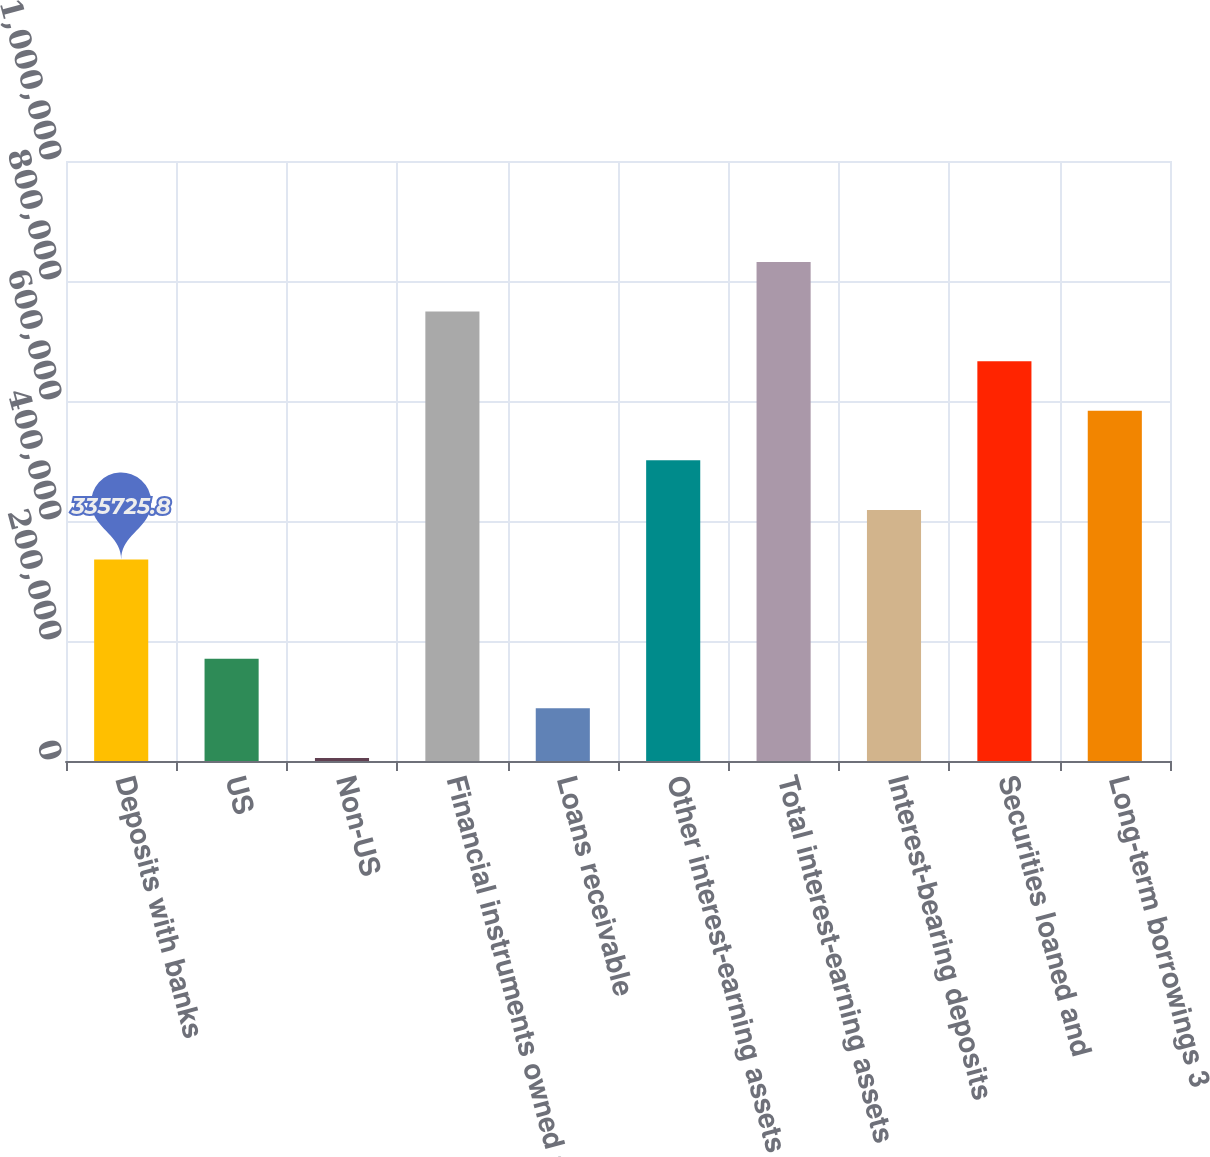<chart> <loc_0><loc_0><loc_500><loc_500><bar_chart><fcel>Deposits with banks<fcel>US<fcel>Non-US<fcel>Financial instruments owned at<fcel>Loans receivable<fcel>Other interest-earning assets<fcel>Total interest-earning assets<fcel>Interest-bearing deposits<fcel>Securities loaned and<fcel>Long-term borrowings 3<nl><fcel>335726<fcel>170399<fcel>5073<fcel>749042<fcel>87736.2<fcel>501052<fcel>831705<fcel>418389<fcel>666379<fcel>583715<nl></chart> 